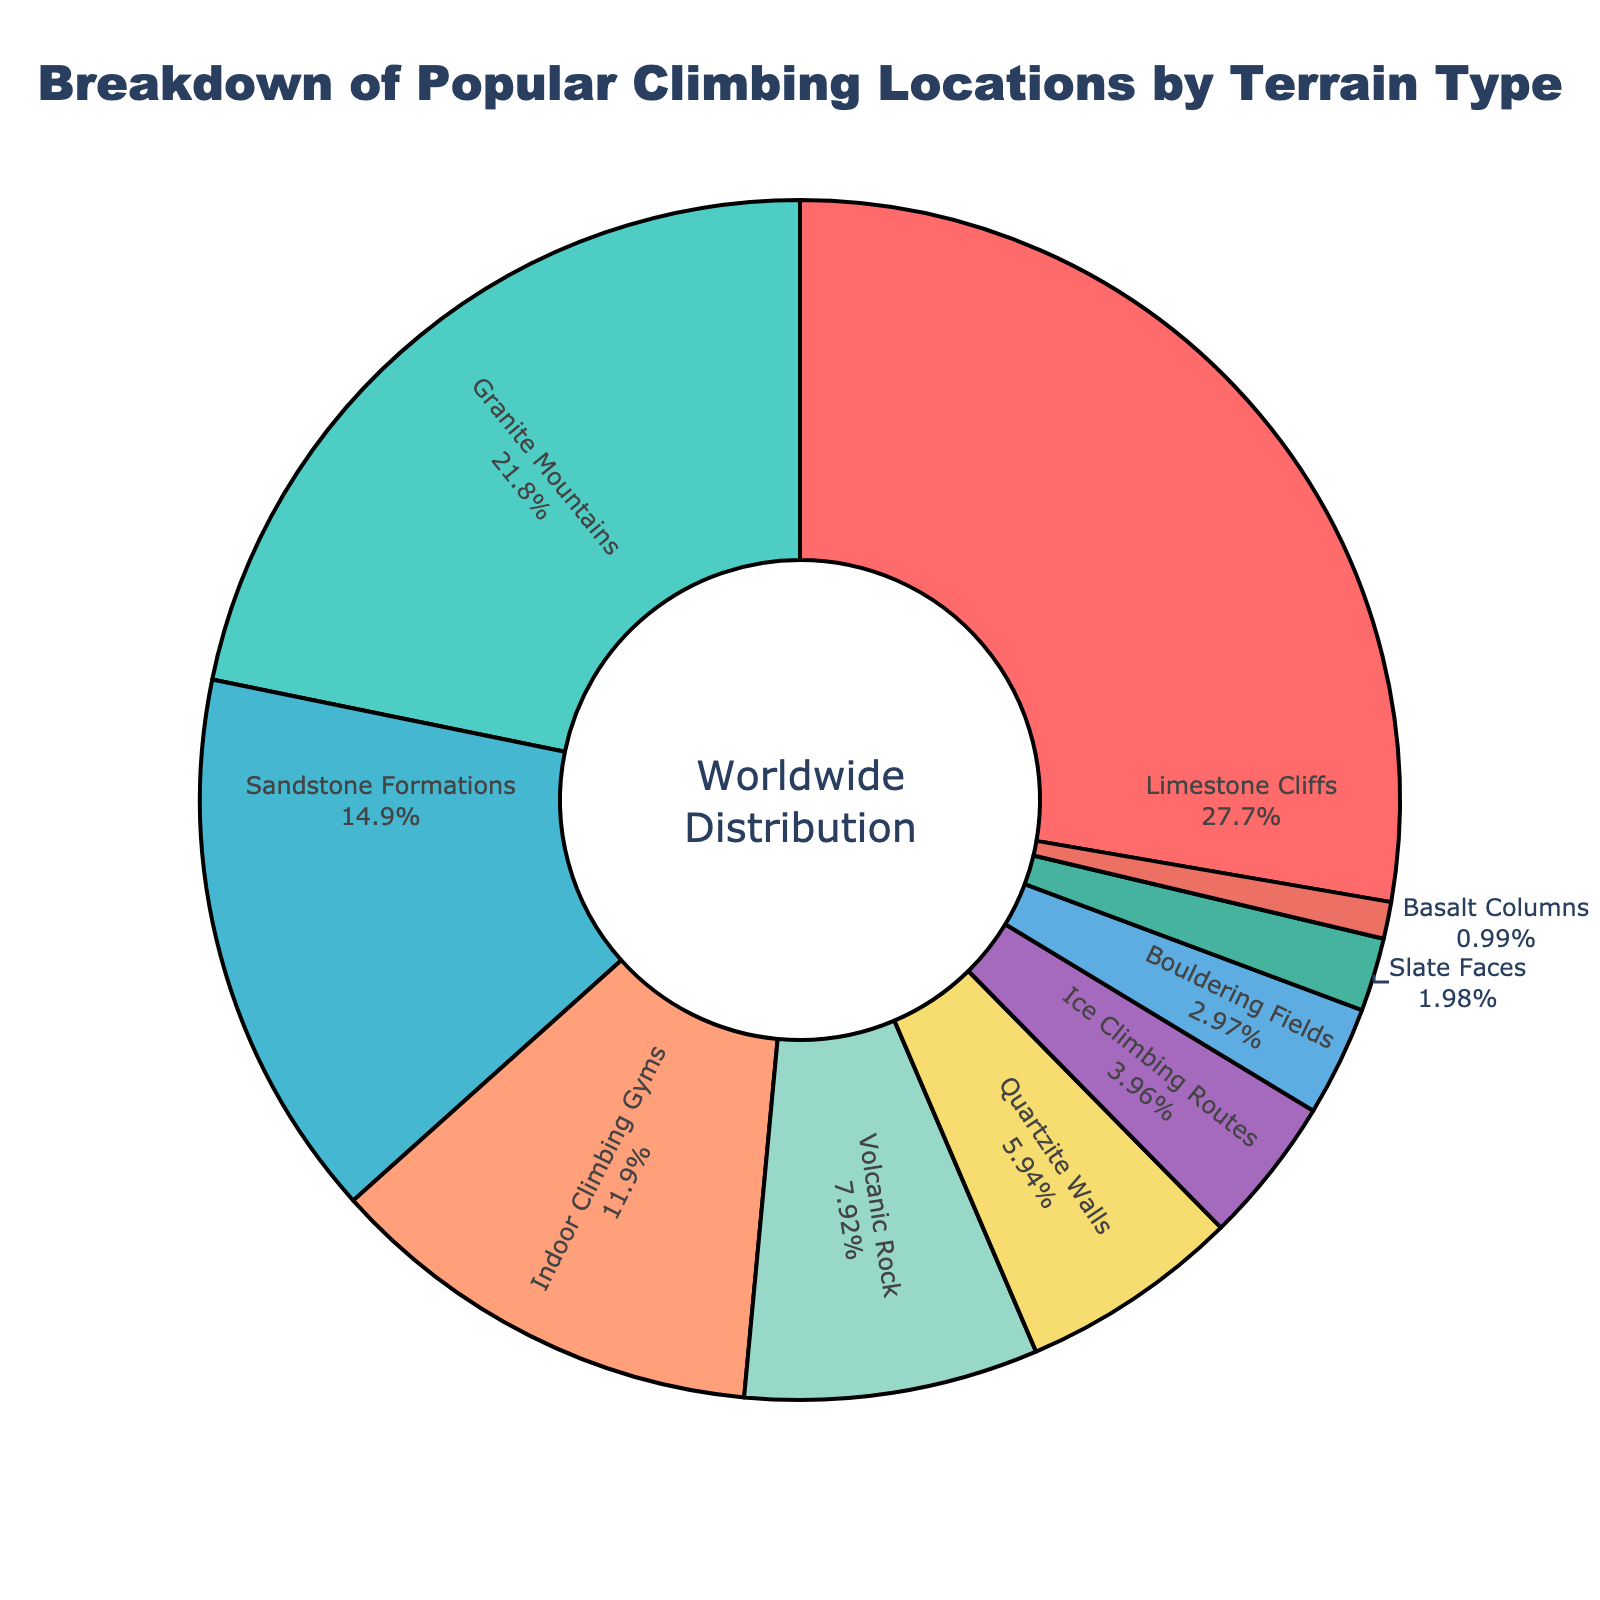Which terrain type has the highest percentage in the pie chart? The terrain type with the highest percentage is identified by looking for the largest slice of the pie chart. The biggest slice is labeled "Limestone Cliffs" with 28%.
Answer: Limestone Cliffs What percentage of the chart is made up of Granite Mountains and Sandstone Formations combined? To find the combined percentage, add the percentages of Granite Mountains (22%) and Sandstone Formations (15%). The sum is: 22% + 15% = 37%.
Answer: 37% Which terrain type occupies the smallest portion of the pie chart? The slice with the smallest percentage corresponds to Basalt Columns, which is labeled with 1%.
Answer: Basalt Columns How does the percentage of Indoor Climbing Gyms compare to the percentage of Ice Climbing Routes? Compare the percentages directly: Indoor Climbing Gyms have 12% while Ice Climbing Routes have 4%. Therefore, Indoor Climbing Gyms have a higher percentage.
Answer: Indoor Climbing Gyms have a higher percentage What is the total percentage represented by both Quartzite Walls and Slate Faces? Sum the percentages of Quartzite Walls (6%) and Slate Faces (2%). The total is: 6% + 2% = 8%.
Answer: 8% Which terrain types together make up exactly half of the chart? Identify the percentages and sum them until you reach 50%. Limestone Cliffs (28%) and Granite Mountains (22%) together make 28% + 22% = 50%.
Answer: Limestone Cliffs and Granite Mountains Is the percentage of Sandstone Formations greater than that of Indoor Climbing Gyms and Ice Climbing Routes combined? First, sum the percentages of Indoor Climbing Gyms (12%) and Ice Climbing Routes (4%): 12% + 4% = 16%. Compare this with Sandstone Formations, which has 15%. 15% < 16%, so Sandstone Formations is not greater.
Answer: No What is the ratio of the percentage of Limestone Cliffs to Quartzite Walls? The ratio is calculated by dividing the percentage of Limestone Cliffs (28%) by the percentage of Quartzite Walls (6%): 28 / 6 = 4.67.
Answer: 4.67 Which terrain types have a percentage less than 5%? The terrain types with percentages less than 5% are identified by looking for slices labeled with percentages below 5%. These are Ice Climbing Routes (4%), Bouldering Fields (3%), Slate Faces (2%), and Basalt Columns (1%).
Answer: Ice Climbing Routes, Bouldering Fields, Slate Faces, Basalt Columns 